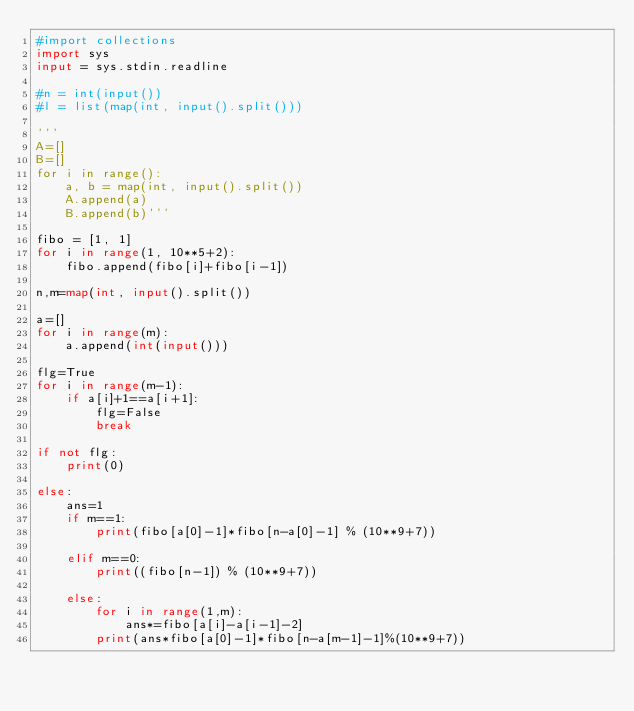<code> <loc_0><loc_0><loc_500><loc_500><_Python_>#import collections
import sys
input = sys.stdin.readline

#n = int(input())
#l = list(map(int, input().split()))

'''
A=[]
B=[]
for i in range():
    a, b = map(int, input().split())
    A.append(a)
    B.append(b)'''

fibo = [1, 1]
for i in range(1, 10**5+2):
    fibo.append(fibo[i]+fibo[i-1])

n,m=map(int, input().split())

a=[]
for i in range(m):
    a.append(int(input()))

flg=True
for i in range(m-1):
    if a[i]+1==a[i+1]:
        flg=False
        break

if not flg:
    print(0)
    
else:
    ans=1
    if m==1:
        print(fibo[a[0]-1]*fibo[n-a[0]-1] % (10**9+7))

    elif m==0:
        print((fibo[n-1]) % (10**9+7))

    else:
        for i in range(1,m):
            ans*=fibo[a[i]-a[i-1]-2]   
        print(ans*fibo[a[0]-1]*fibo[n-a[m-1]-1]%(10**9+7))


</code> 